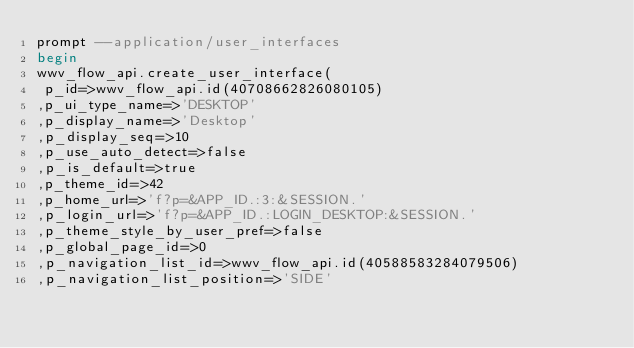Convert code to text. <code><loc_0><loc_0><loc_500><loc_500><_SQL_>prompt --application/user_interfaces
begin
wwv_flow_api.create_user_interface(
 p_id=>wwv_flow_api.id(40708662826080105)
,p_ui_type_name=>'DESKTOP'
,p_display_name=>'Desktop'
,p_display_seq=>10
,p_use_auto_detect=>false
,p_is_default=>true
,p_theme_id=>42
,p_home_url=>'f?p=&APP_ID.:3:&SESSION.'
,p_login_url=>'f?p=&APP_ID.:LOGIN_DESKTOP:&SESSION.'
,p_theme_style_by_user_pref=>false
,p_global_page_id=>0
,p_navigation_list_id=>wwv_flow_api.id(40588583284079506)
,p_navigation_list_position=>'SIDE'</code> 